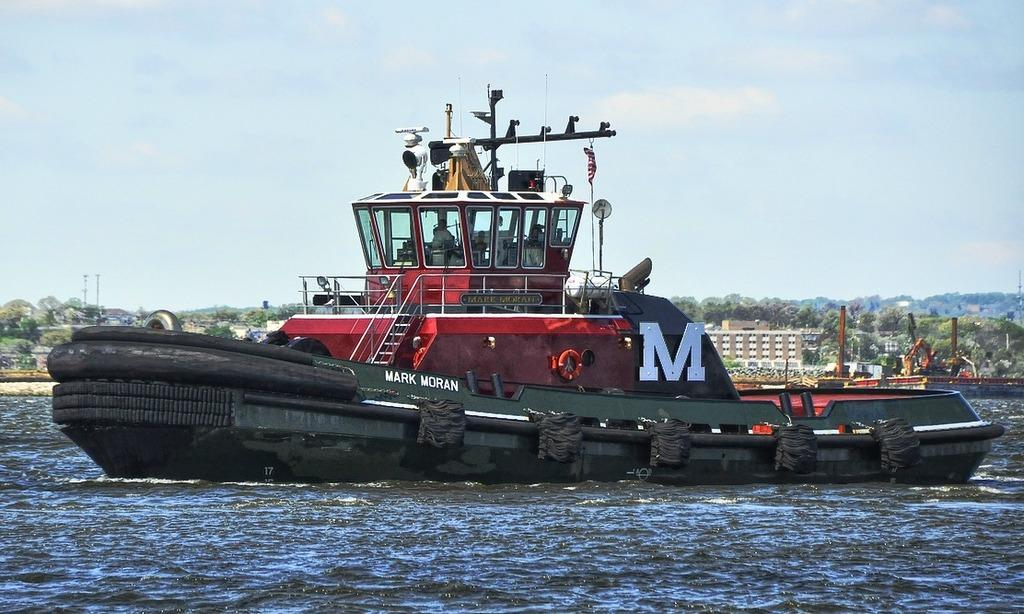What type of vehicle is in the image? There is a tugboat in the image. Where is the tugboat located? The tugboat is on the water. Is there anyone on the tugboat? Yes, there is a person sitting in the tugboat. What else can be seen in the image besides the tugboat? There is a building, trees, and the sky visible in the image. Can you see your aunt playing with balls in the image? There is no mention of an aunt or balls in the image; it features a tugboat on the water with a person sitting in it, along with a building, trees, and the sky. 